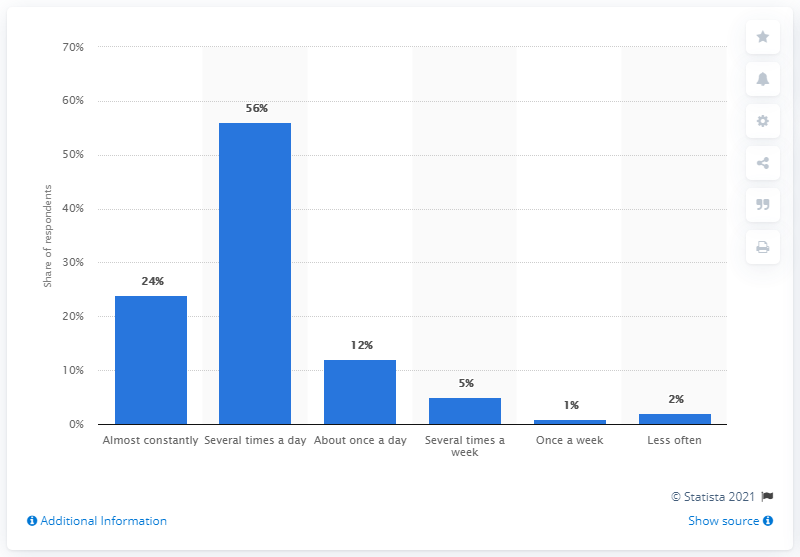Outline some significant characteristics in this image. The difference between the maximum and minimum frequency of internet usage in the US is 55%. The maximum value of the bar graph is 56. 